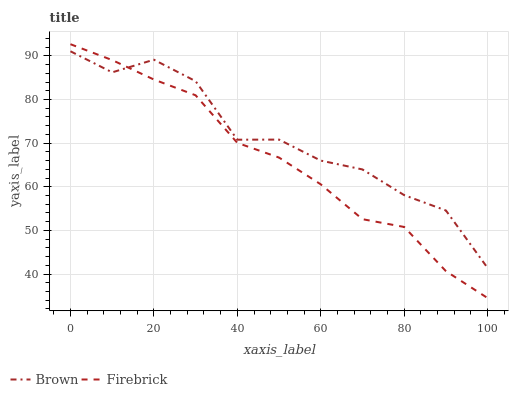Does Firebrick have the minimum area under the curve?
Answer yes or no. Yes. Does Brown have the maximum area under the curve?
Answer yes or no. Yes. Does Firebrick have the maximum area under the curve?
Answer yes or no. No. Is Firebrick the smoothest?
Answer yes or no. Yes. Is Brown the roughest?
Answer yes or no. Yes. Is Firebrick the roughest?
Answer yes or no. No. Does Firebrick have the lowest value?
Answer yes or no. Yes. Does Firebrick have the highest value?
Answer yes or no. Yes. Does Firebrick intersect Brown?
Answer yes or no. Yes. Is Firebrick less than Brown?
Answer yes or no. No. Is Firebrick greater than Brown?
Answer yes or no. No. 